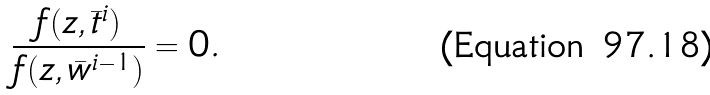<formula> <loc_0><loc_0><loc_500><loc_500>\frac { f ( z , \bar { t } ^ { i } ) } { f ( z , \bar { w } ^ { i - 1 } ) } = 0 .</formula> 